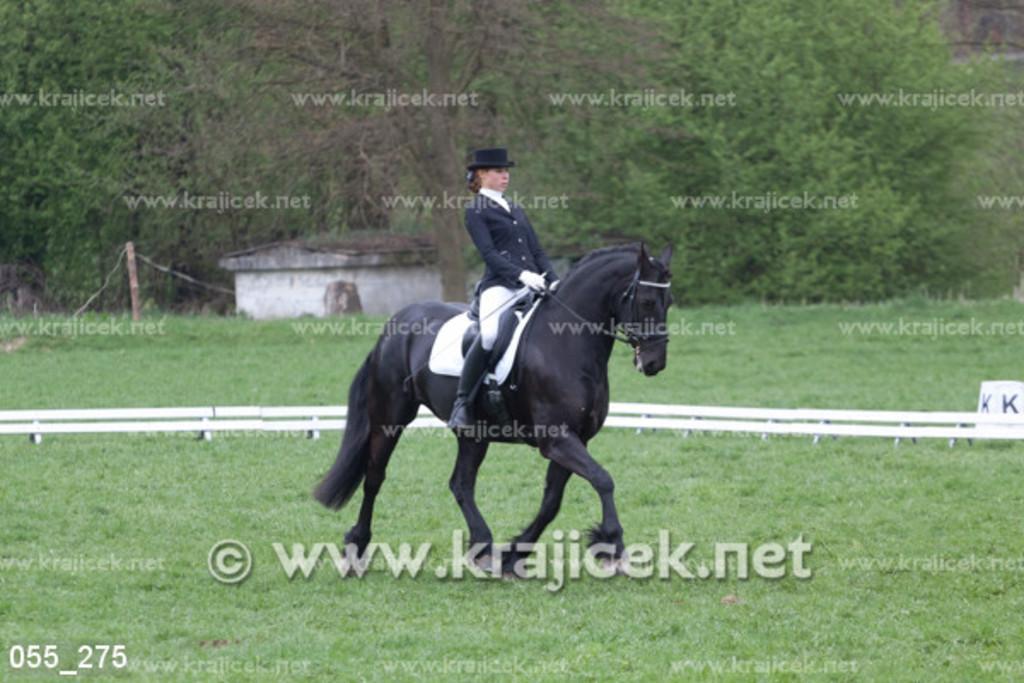Can you describe this image briefly? In this image there is a horse walking on the ground. There is a person sitting on the horse. The person is holding a stick in the hand. There is grass on the ground. Behind them there are boards on the ground. In the background there are trees and a house. There is text on the image. 